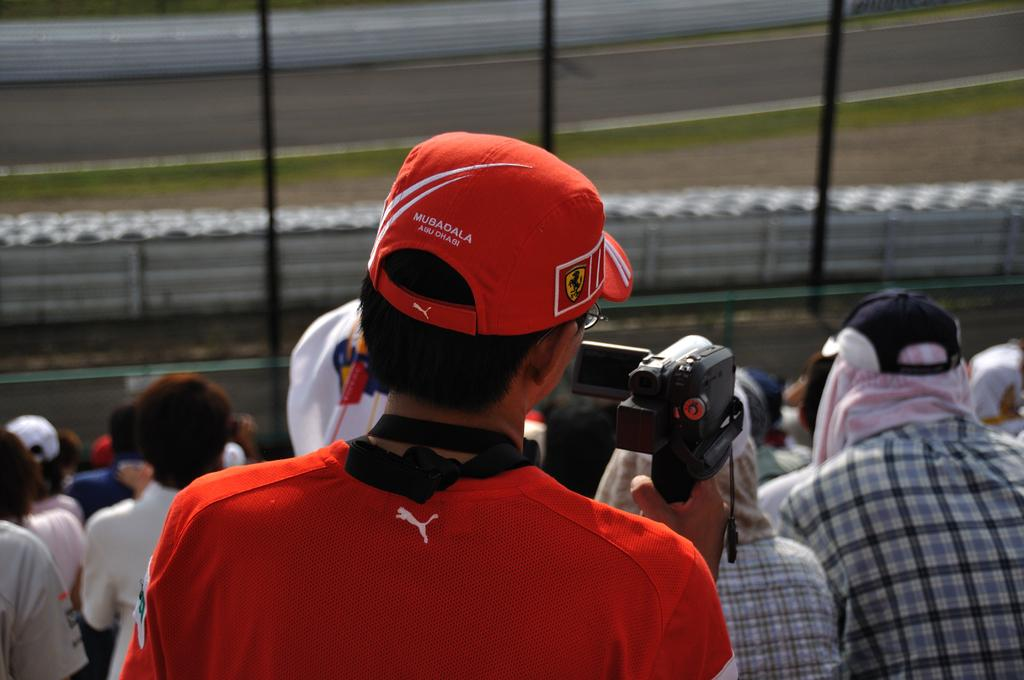Who can be seen in the image? There are people in the image. What is the man holding in his hand? The man is holding a video camera in his hand. What type of barrier is present in the image? There is a metal fence in the image. What type of pathway is visible in the image? There is a road in the image. What type of headwear can be seen on some people in the image? Some people are wearing caps on their heads. What type of tax is being discussed by the people in the image? There is no indication in the image that the people are discussing any type of tax. 